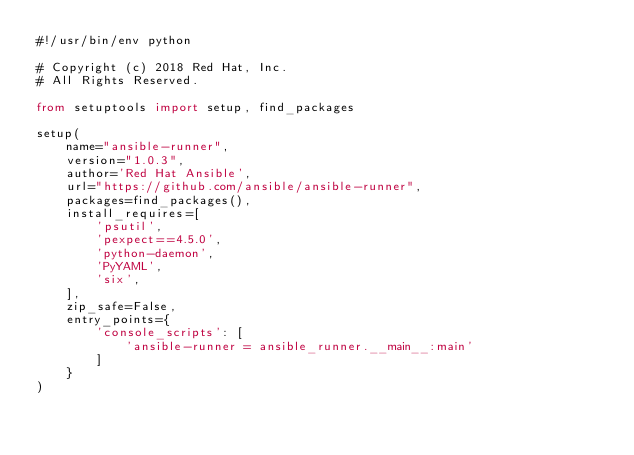Convert code to text. <code><loc_0><loc_0><loc_500><loc_500><_Python_>#!/usr/bin/env python

# Copyright (c) 2018 Red Hat, Inc.
# All Rights Reserved.

from setuptools import setup, find_packages

setup(
    name="ansible-runner",
    version="1.0.3",
    author='Red Hat Ansible',
    url="https://github.com/ansible/ansible-runner",
    packages=find_packages(),
    install_requires=[
        'psutil',
        'pexpect==4.5.0',
        'python-daemon',
        'PyYAML',
        'six',
    ],
    zip_safe=False,
    entry_points={
        'console_scripts': [
            'ansible-runner = ansible_runner.__main__:main'
        ]
    }
)
</code> 